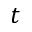Convert formula to latex. <formula><loc_0><loc_0><loc_500><loc_500>t</formula> 